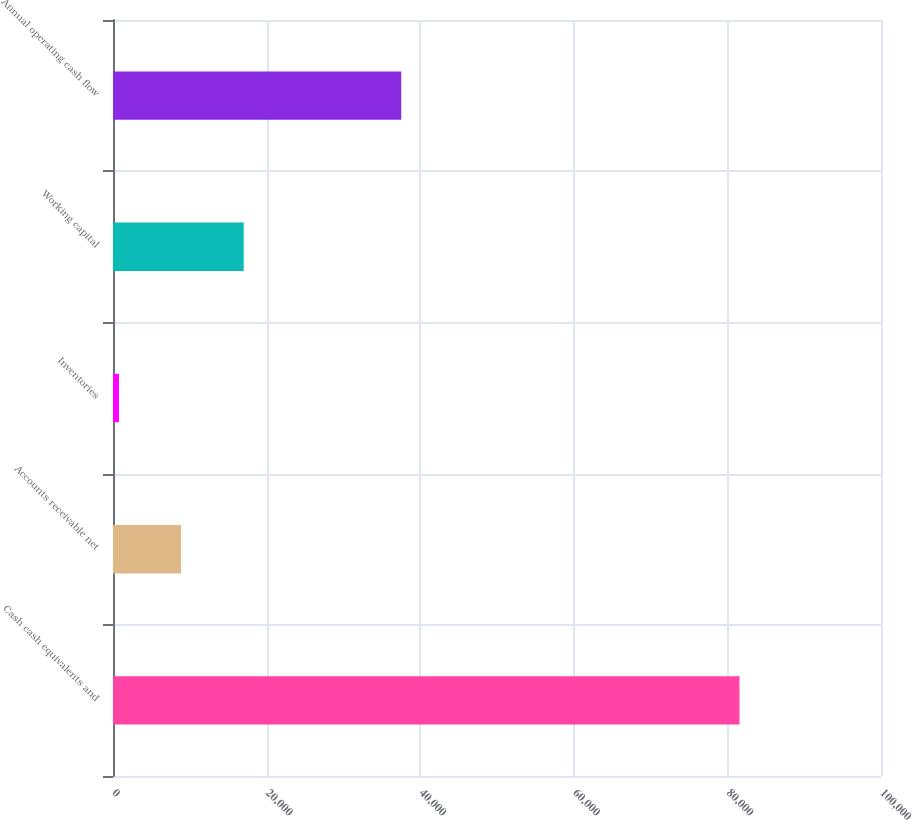Convert chart to OTSL. <chart><loc_0><loc_0><loc_500><loc_500><bar_chart><fcel>Cash cash equivalents and<fcel>Accounts receivable net<fcel>Inventories<fcel>Working capital<fcel>Annual operating cash flow<nl><fcel>81570<fcel>8855.4<fcel>776<fcel>17018<fcel>37529<nl></chart> 